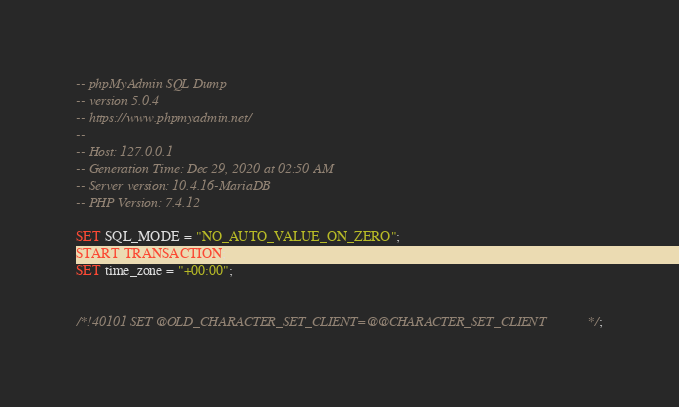<code> <loc_0><loc_0><loc_500><loc_500><_SQL_>-- phpMyAdmin SQL Dump
-- version 5.0.4
-- https://www.phpmyadmin.net/
--
-- Host: 127.0.0.1
-- Generation Time: Dec 29, 2020 at 02:50 AM
-- Server version: 10.4.16-MariaDB
-- PHP Version: 7.4.12

SET SQL_MODE = "NO_AUTO_VALUE_ON_ZERO";
START TRANSACTION;
SET time_zone = "+00:00";


/*!40101 SET @OLD_CHARACTER_SET_CLIENT=@@CHARACTER_SET_CLIENT */;</code> 